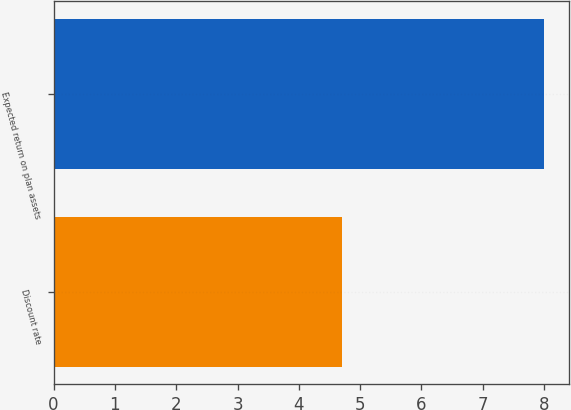Convert chart to OTSL. <chart><loc_0><loc_0><loc_500><loc_500><bar_chart><fcel>Discount rate<fcel>Expected return on plan assets<nl><fcel>4.7<fcel>8<nl></chart> 